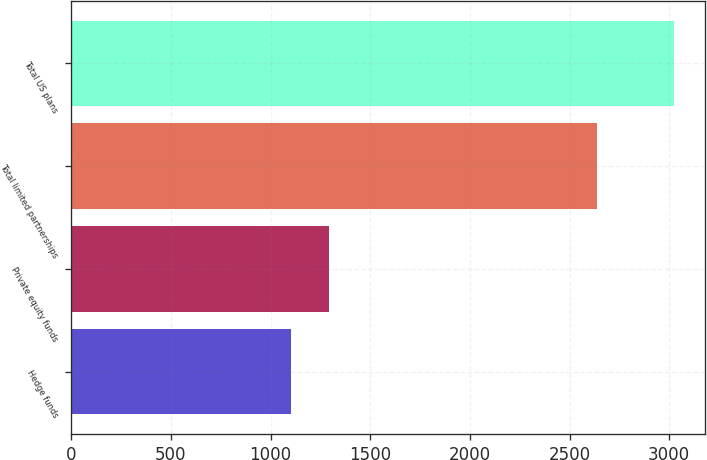Convert chart to OTSL. <chart><loc_0><loc_0><loc_500><loc_500><bar_chart><fcel>Hedge funds<fcel>Private equity funds<fcel>Total limited partnerships<fcel>Total US plans<nl><fcel>1102<fcel>1294.4<fcel>2638<fcel>3026<nl></chart> 